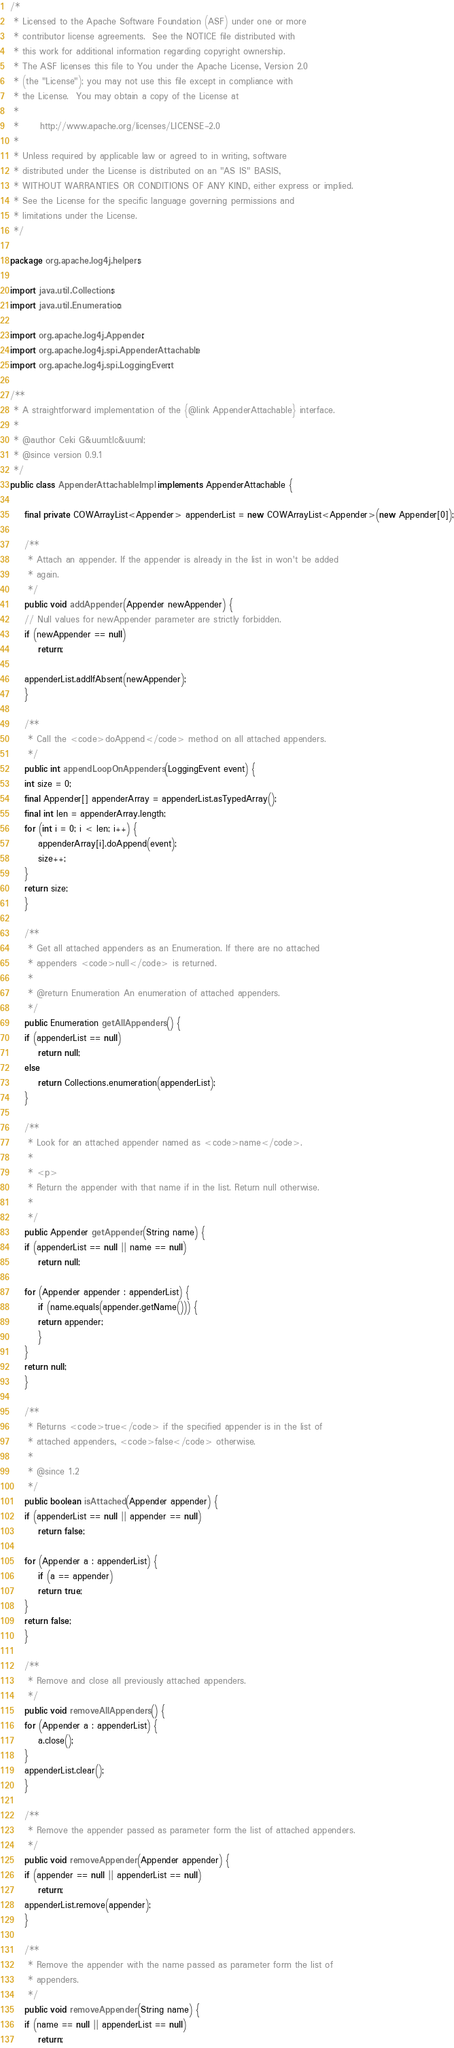Convert code to text. <code><loc_0><loc_0><loc_500><loc_500><_Java_>/*
 * Licensed to the Apache Software Foundation (ASF) under one or more
 * contributor license agreements.  See the NOTICE file distributed with
 * this work for additional information regarding copyright ownership.
 * The ASF licenses this file to You under the Apache License, Version 2.0
 * (the "License"); you may not use this file except in compliance with
 * the License.  You may obtain a copy of the License at
 * 
 *      http://www.apache.org/licenses/LICENSE-2.0
 * 
 * Unless required by applicable law or agreed to in writing, software
 * distributed under the License is distributed on an "AS IS" BASIS,
 * WITHOUT WARRANTIES OR CONDITIONS OF ANY KIND, either express or implied.
 * See the License for the specific language governing permissions and
 * limitations under the License.
 */

package org.apache.log4j.helpers;

import java.util.Collections;
import java.util.Enumeration;

import org.apache.log4j.Appender;
import org.apache.log4j.spi.AppenderAttachable;
import org.apache.log4j.spi.LoggingEvent;

/**
 * A straightforward implementation of the {@link AppenderAttachable} interface.
 * 
 * @author Ceki G&uuml;lc&uuml;
 * @since version 0.9.1
 */
public class AppenderAttachableImpl implements AppenderAttachable {

    final private COWArrayList<Appender> appenderList = new COWArrayList<Appender>(new Appender[0]);

    /**
     * Attach an appender. If the appender is already in the list in won't be added
     * again.
     */
    public void addAppender(Appender newAppender) {
	// Null values for newAppender parameter are strictly forbidden.
	if (newAppender == null)
	    return;

	appenderList.addIfAbsent(newAppender);
    }

    /**
     * Call the <code>doAppend</code> method on all attached appenders.
     */
    public int appendLoopOnAppenders(LoggingEvent event) {
	int size = 0;
	final Appender[] appenderArray = appenderList.asTypedArray();
	final int len = appenderArray.length;
	for (int i = 0; i < len; i++) {
	    appenderArray[i].doAppend(event);
	    size++;
	}
	return size;
    }

    /**
     * Get all attached appenders as an Enumeration. If there are no attached
     * appenders <code>null</code> is returned.
     * 
     * @return Enumeration An enumeration of attached appenders.
     */
    public Enumeration getAllAppenders() {
	if (appenderList == null)
	    return null;
	else
	    return Collections.enumeration(appenderList); 
    }

    /**
     * Look for an attached appender named as <code>name</code>.
     * 
     * <p>
     * Return the appender with that name if in the list. Return null otherwise.
     * 
     */
    public Appender getAppender(String name) {
	if (appenderList == null || name == null)
	    return null;

	for (Appender appender : appenderList) {
	    if (name.equals(appender.getName())) {
		return appender;
	    }
	}
	return null;
    }

    /**
     * Returns <code>true</code> if the specified appender is in the list of
     * attached appenders, <code>false</code> otherwise.
     * 
     * @since 1.2
     */
    public boolean isAttached(Appender appender) {
	if (appenderList == null || appender == null)
	    return false;

	for (Appender a : appenderList) {
	    if (a == appender)
		return true;
	}
	return false;
    }

    /**
     * Remove and close all previously attached appenders.
     */
    public void removeAllAppenders() {
	for (Appender a : appenderList) {
	    a.close();
	}
	appenderList.clear();
    }

    /**
     * Remove the appender passed as parameter form the list of attached appenders.
     */
    public void removeAppender(Appender appender) {
	if (appender == null || appenderList == null)
	    return;
	appenderList.remove(appender);
    }

    /**
     * Remove the appender with the name passed as parameter form the list of
     * appenders.
     */
    public void removeAppender(String name) {
	if (name == null || appenderList == null)
	    return;
</code> 